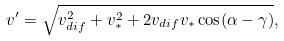<formula> <loc_0><loc_0><loc_500><loc_500>v ^ { \prime } = \sqrt { v _ { d i f } ^ { 2 } + v _ { * } ^ { 2 } + 2 v _ { d i f } v _ { * } \cos ( \alpha - \gamma ) } ,</formula> 